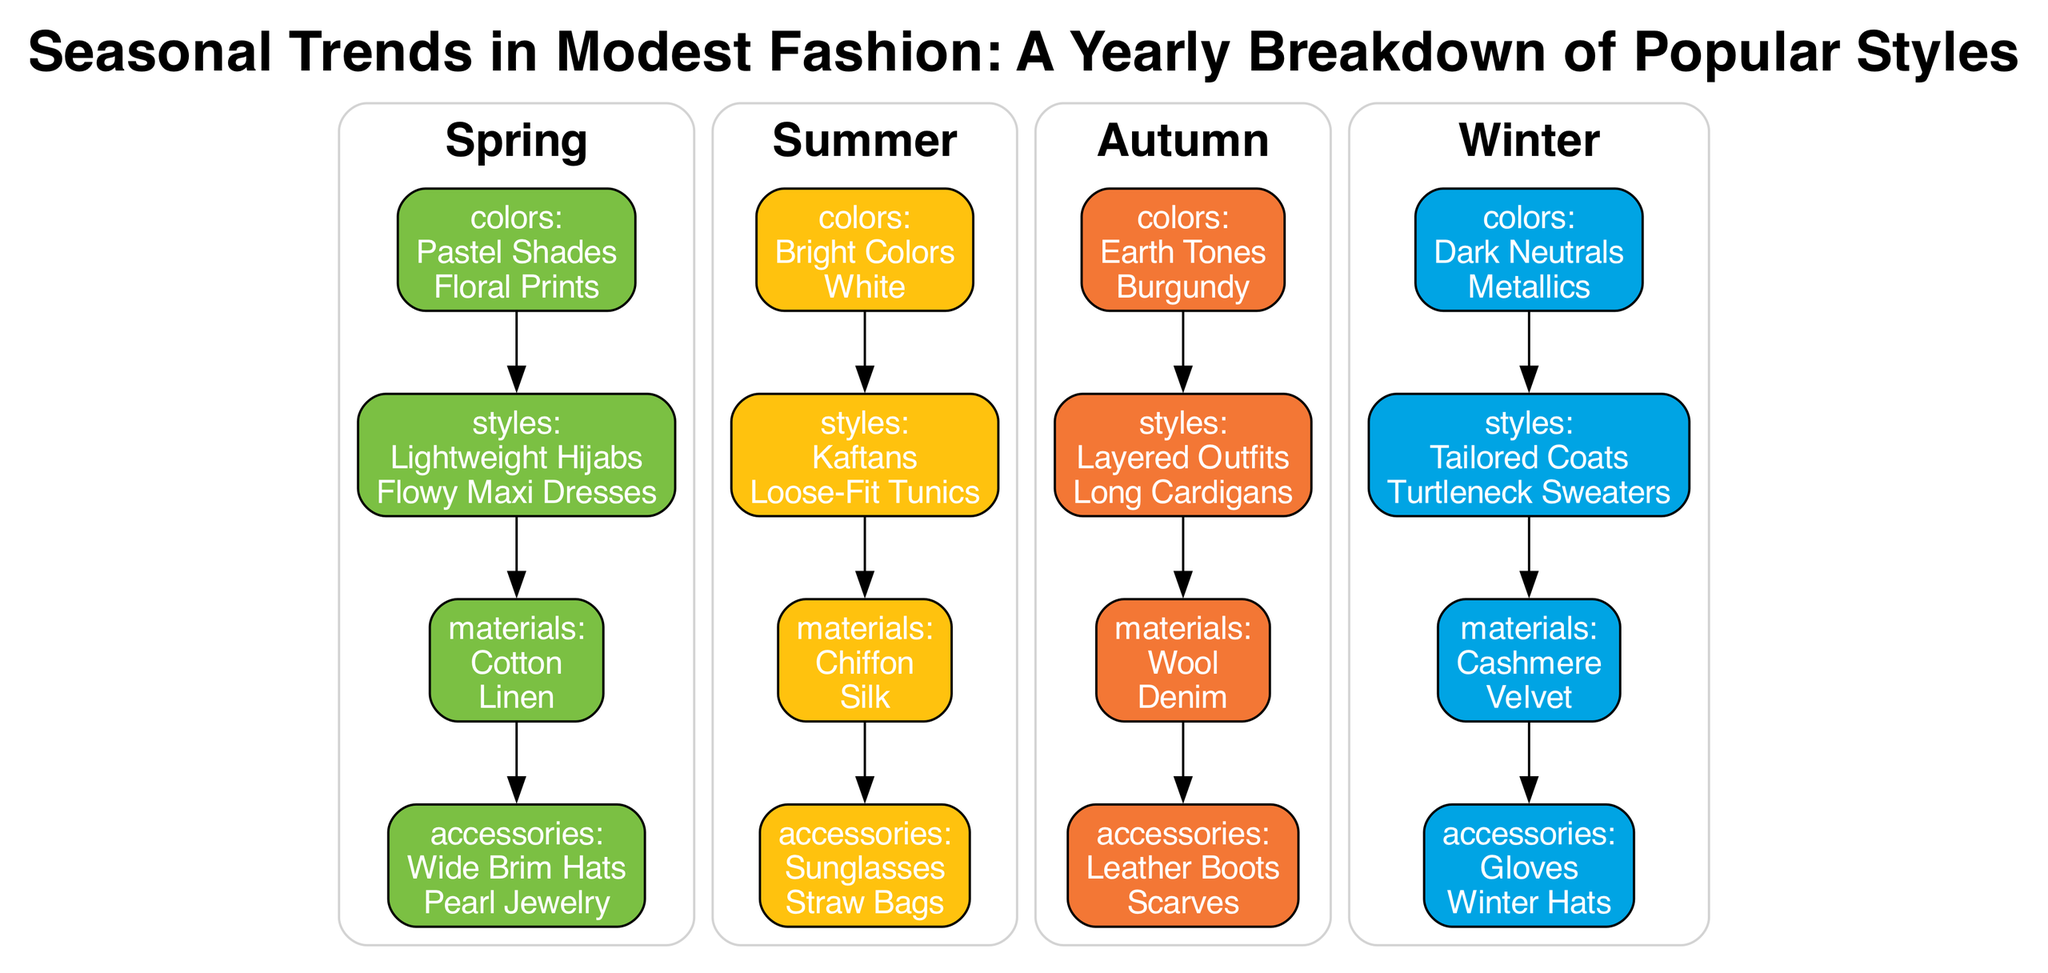What are the colors associated with Spring? The diagram lists "Pastel Shades" and "Floral Prints" as the colors associated with Spring. This information can be directly found in the section corresponding to Spring under the colors category.
Answer: Pastel Shades, Floral Prints Which style is listed for Summer? "Kaftans" is indicated as one of the styles for Summer. This can be identified in the Summer section of the diagram under the styles category.
Answer: Kaftans How many categories are there within each season? Each season, represented by a subgraph, contains four categories: colors, styles, materials, and accessories. Hence, the total number of categories is four. This is evident in each seasonal section of the diagram.
Answer: 4 Which accessory is associated with Autumn? The diagram shows "Leather Boots" and "Scarves" as accessories associated with Autumn. Accessory items fall under the accessories category in the Autumn section.
Answer: Leather Boots, Scarves What are the materials used in Winter styles? The materials listed for Winter styles include "Cashmere" and "Velvet." This information can be found in the materials category under the Winter section.
Answer: Cashmere, Velvet Which season features the color "White"? The color "White" is specifically listed under the Summer category. To answer this question, one would refer to the colors associated with each season and identify that it belongs to Summer.
Answer: Summer How do styles flow from colors in Autumn? The diagram establishes a direct connection (edge) from the colors node to the styles node in the Autumn subgraph. By following this edge, one can see that styles follow after colors in the flow of information.
Answer: Styles flow from colors What is the primary color scheme for Winter? The primary color scheme for Winter includes "Dark Neutrals" and "Metallics." This can be found in the colors category for Winter in the diagram.
Answer: Dark Neutrals, Metallics Which materials are used in Spring outfits? In Spring, the listed materials are "Cotton" and "Linen." This can be verified by checking the materials category under the Spring section of the diagram.
Answer: Cotton, Linen 